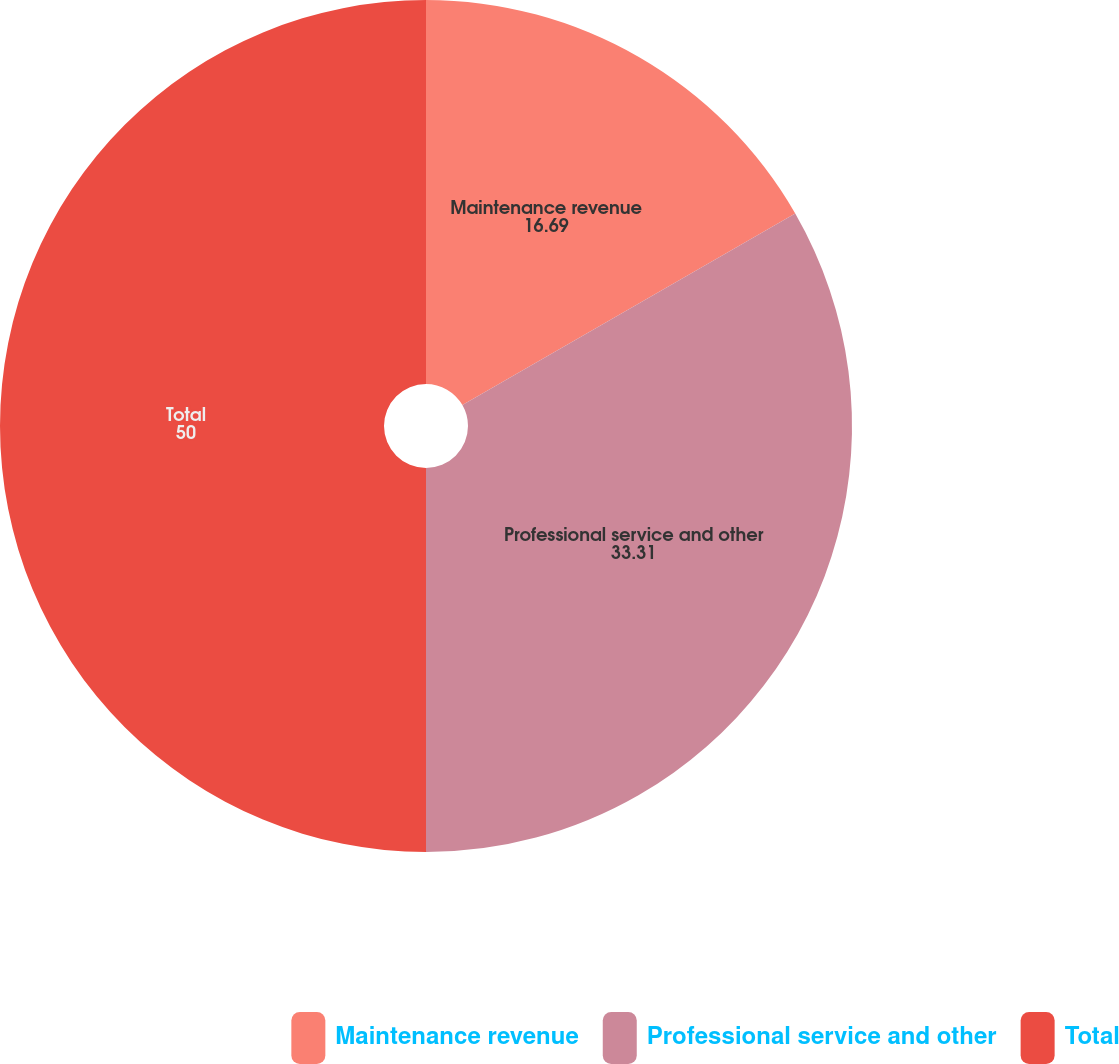<chart> <loc_0><loc_0><loc_500><loc_500><pie_chart><fcel>Maintenance revenue<fcel>Professional service and other<fcel>Total<nl><fcel>16.69%<fcel>33.31%<fcel>50.0%<nl></chart> 